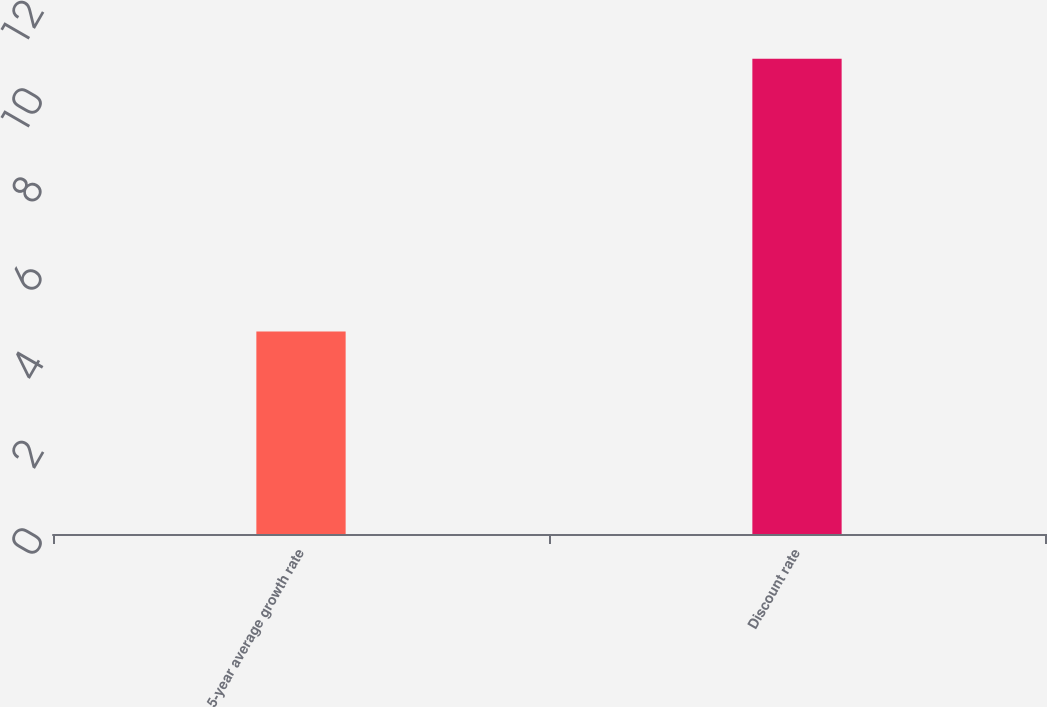<chart> <loc_0><loc_0><loc_500><loc_500><bar_chart><fcel>5-year average growth rate<fcel>Discount rate<nl><fcel>4.6<fcel>10.8<nl></chart> 